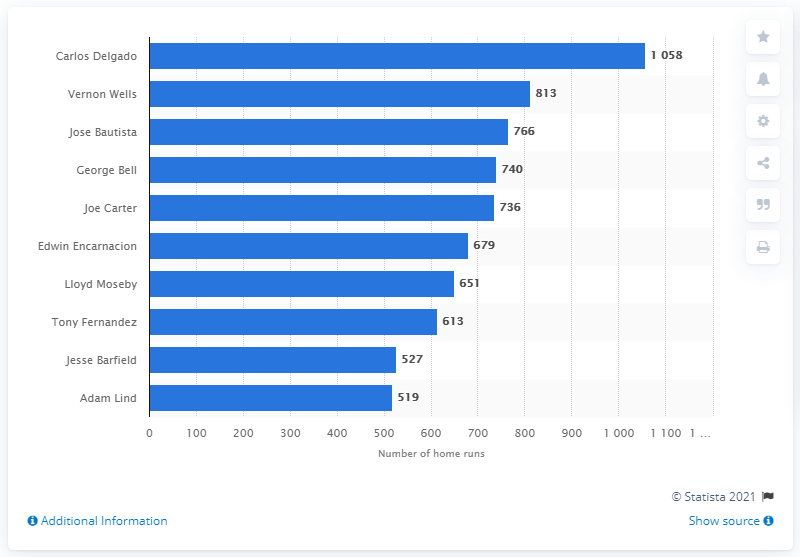Who holds the record for the most home runs in Toronto Blue Jays history as depicted in the image? Carlos Delgado holds the record for the most home runs in Toronto Blue Jays history with 1,058 home runs as shown in the image. 